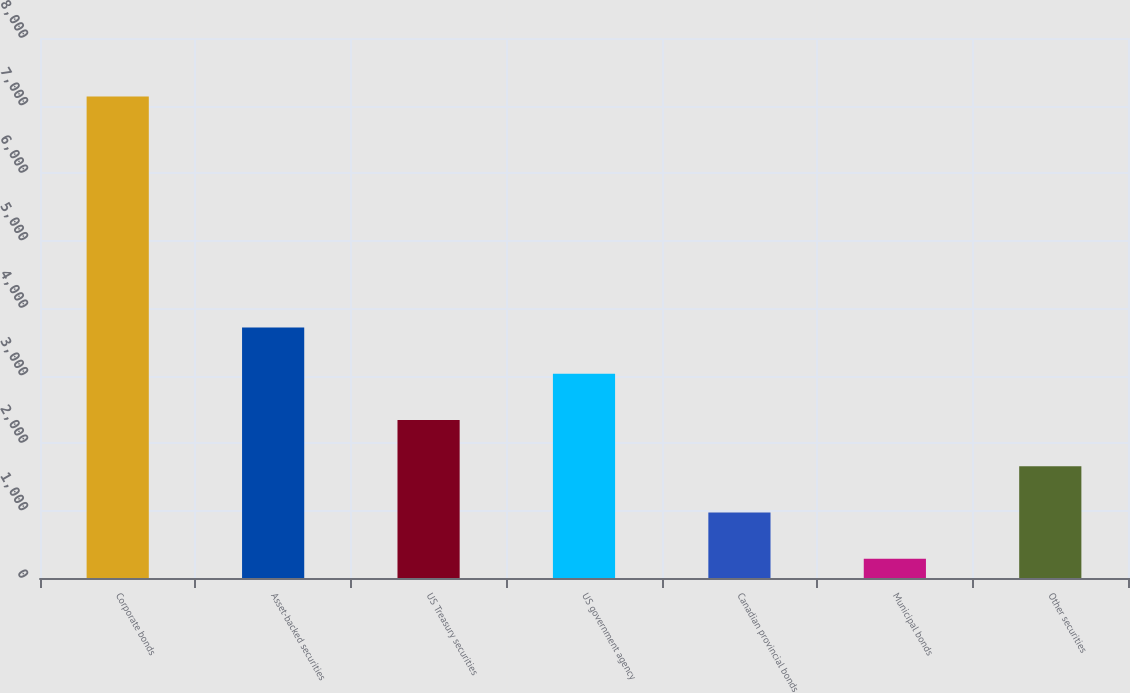Convert chart to OTSL. <chart><loc_0><loc_0><loc_500><loc_500><bar_chart><fcel>Corporate bonds<fcel>Asset-backed securities<fcel>US Treasury securities<fcel>US government agency<fcel>Canadian provincial bonds<fcel>Municipal bonds<fcel>Other securities<nl><fcel>7132.9<fcel>3709.35<fcel>2339.93<fcel>3024.64<fcel>970.51<fcel>285.8<fcel>1655.22<nl></chart> 